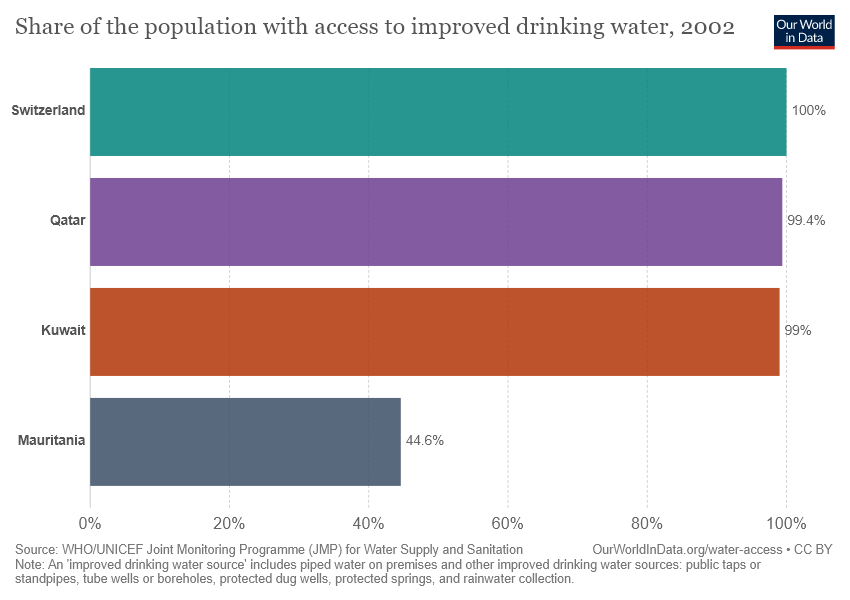List a handful of essential elements in this visual. Switzerland is significantly larger than Mauritania. Switzerland is 100% represented in the chart. 